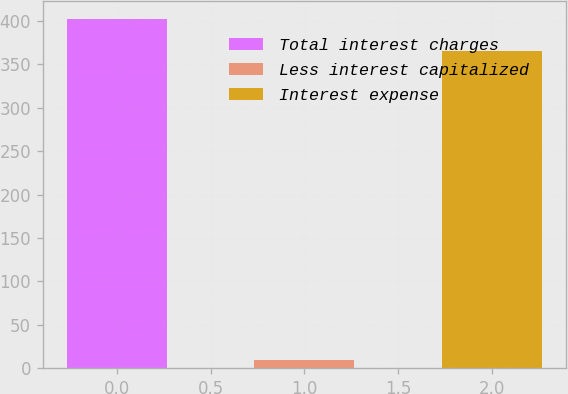Convert chart. <chart><loc_0><loc_0><loc_500><loc_500><bar_chart><fcel>Total interest charges<fcel>Less interest capitalized<fcel>Interest expense<nl><fcel>402.6<fcel>9<fcel>366<nl></chart> 